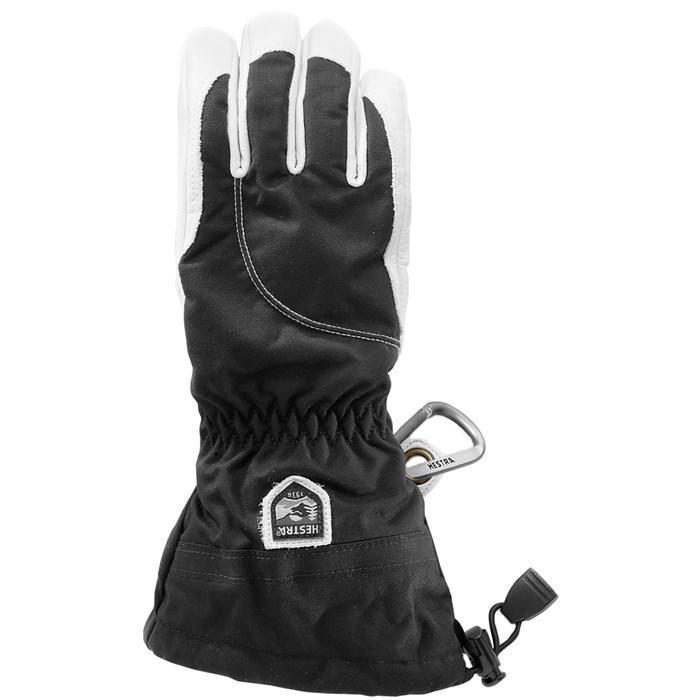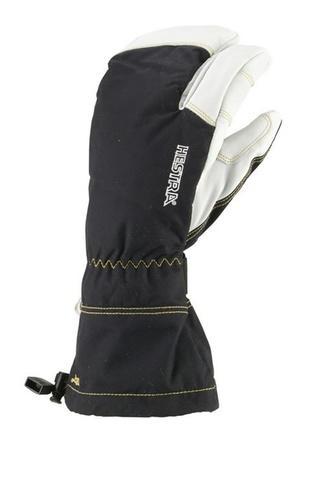The first image is the image on the left, the second image is the image on the right. Given the left and right images, does the statement "None of the gloves or mittens make a pair." hold true? Answer yes or no. Yes. The first image is the image on the left, the second image is the image on the right. Given the left and right images, does the statement "One image contains a pair of white and dark two-toned gloves, and the other contains a single glove." hold true? Answer yes or no. No. 